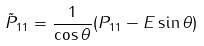<formula> <loc_0><loc_0><loc_500><loc_500>\tilde { P } _ { 1 1 } = \frac { 1 } { \cos \theta } ( P _ { 1 1 } - E \sin \theta )</formula> 